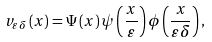<formula> <loc_0><loc_0><loc_500><loc_500>v _ { \varepsilon \delta } \left ( x \right ) = \Psi \left ( x \right ) \psi \left ( \frac { x } { \varepsilon } \right ) \phi \left ( \frac { x } { \varepsilon \delta } \right ) ,</formula> 